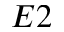<formula> <loc_0><loc_0><loc_500><loc_500>E 2</formula> 